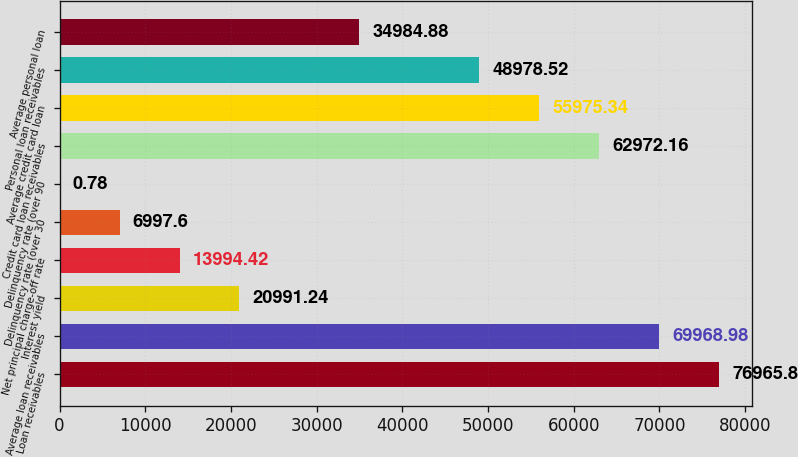Convert chart to OTSL. <chart><loc_0><loc_0><loc_500><loc_500><bar_chart><fcel>Loan receivables<fcel>Average loan receivables<fcel>Interest yield<fcel>Net principal charge-off rate<fcel>Delinquency rate (over 30<fcel>Delinquency rate (over 90<fcel>Credit card loan receivables<fcel>Average credit card loan<fcel>Personal loan receivables<fcel>Average personal loan<nl><fcel>76965.8<fcel>69969<fcel>20991.2<fcel>13994.4<fcel>6997.6<fcel>0.78<fcel>62972.2<fcel>55975.3<fcel>48978.5<fcel>34984.9<nl></chart> 